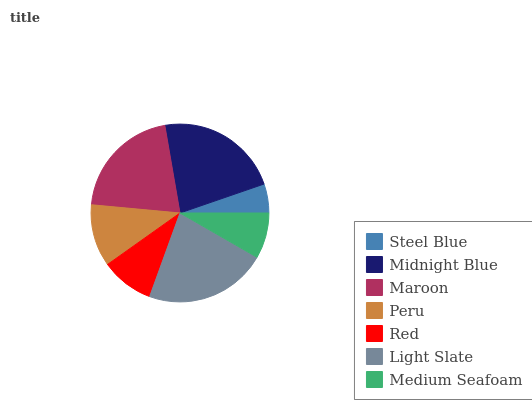Is Steel Blue the minimum?
Answer yes or no. Yes. Is Midnight Blue the maximum?
Answer yes or no. Yes. Is Maroon the minimum?
Answer yes or no. No. Is Maroon the maximum?
Answer yes or no. No. Is Midnight Blue greater than Maroon?
Answer yes or no. Yes. Is Maroon less than Midnight Blue?
Answer yes or no. Yes. Is Maroon greater than Midnight Blue?
Answer yes or no. No. Is Midnight Blue less than Maroon?
Answer yes or no. No. Is Peru the high median?
Answer yes or no. Yes. Is Peru the low median?
Answer yes or no. Yes. Is Light Slate the high median?
Answer yes or no. No. Is Light Slate the low median?
Answer yes or no. No. 